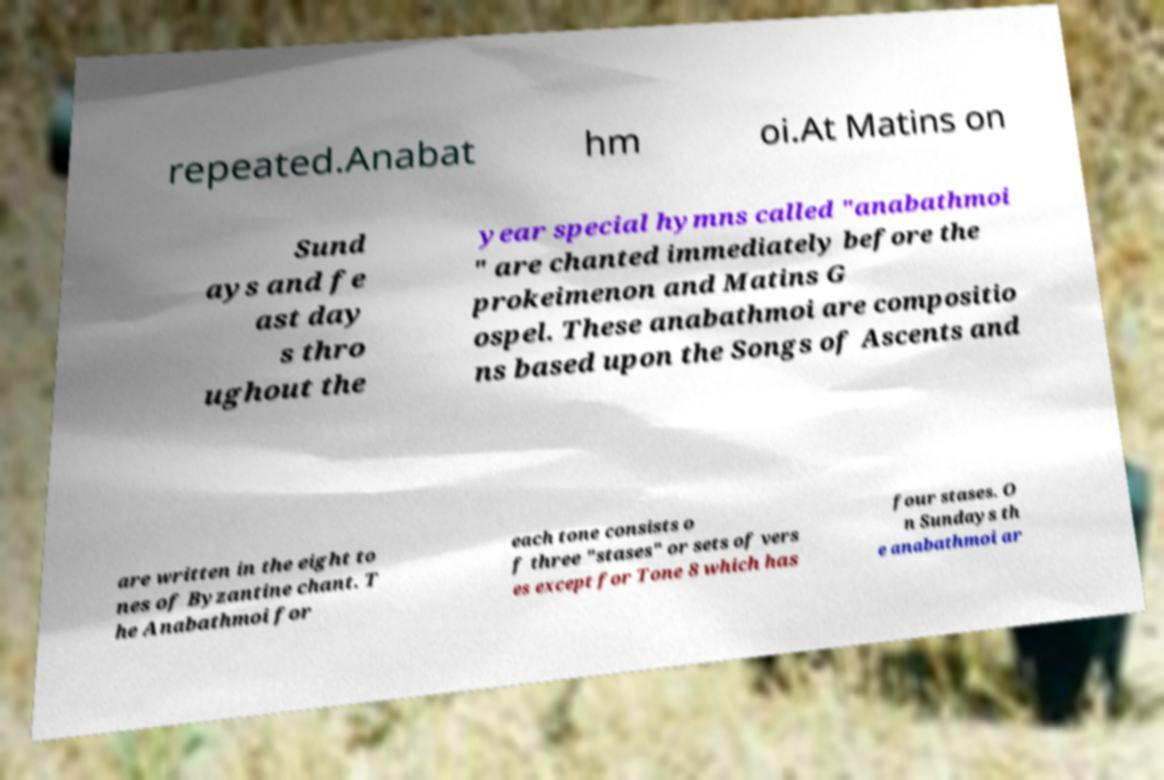Could you assist in decoding the text presented in this image and type it out clearly? repeated.Anabat hm oi.At Matins on Sund ays and fe ast day s thro ughout the year special hymns called "anabathmoi " are chanted immediately before the prokeimenon and Matins G ospel. These anabathmoi are compositio ns based upon the Songs of Ascents and are written in the eight to nes of Byzantine chant. T he Anabathmoi for each tone consists o f three "stases" or sets of vers es except for Tone 8 which has four stases. O n Sundays th e anabathmoi ar 